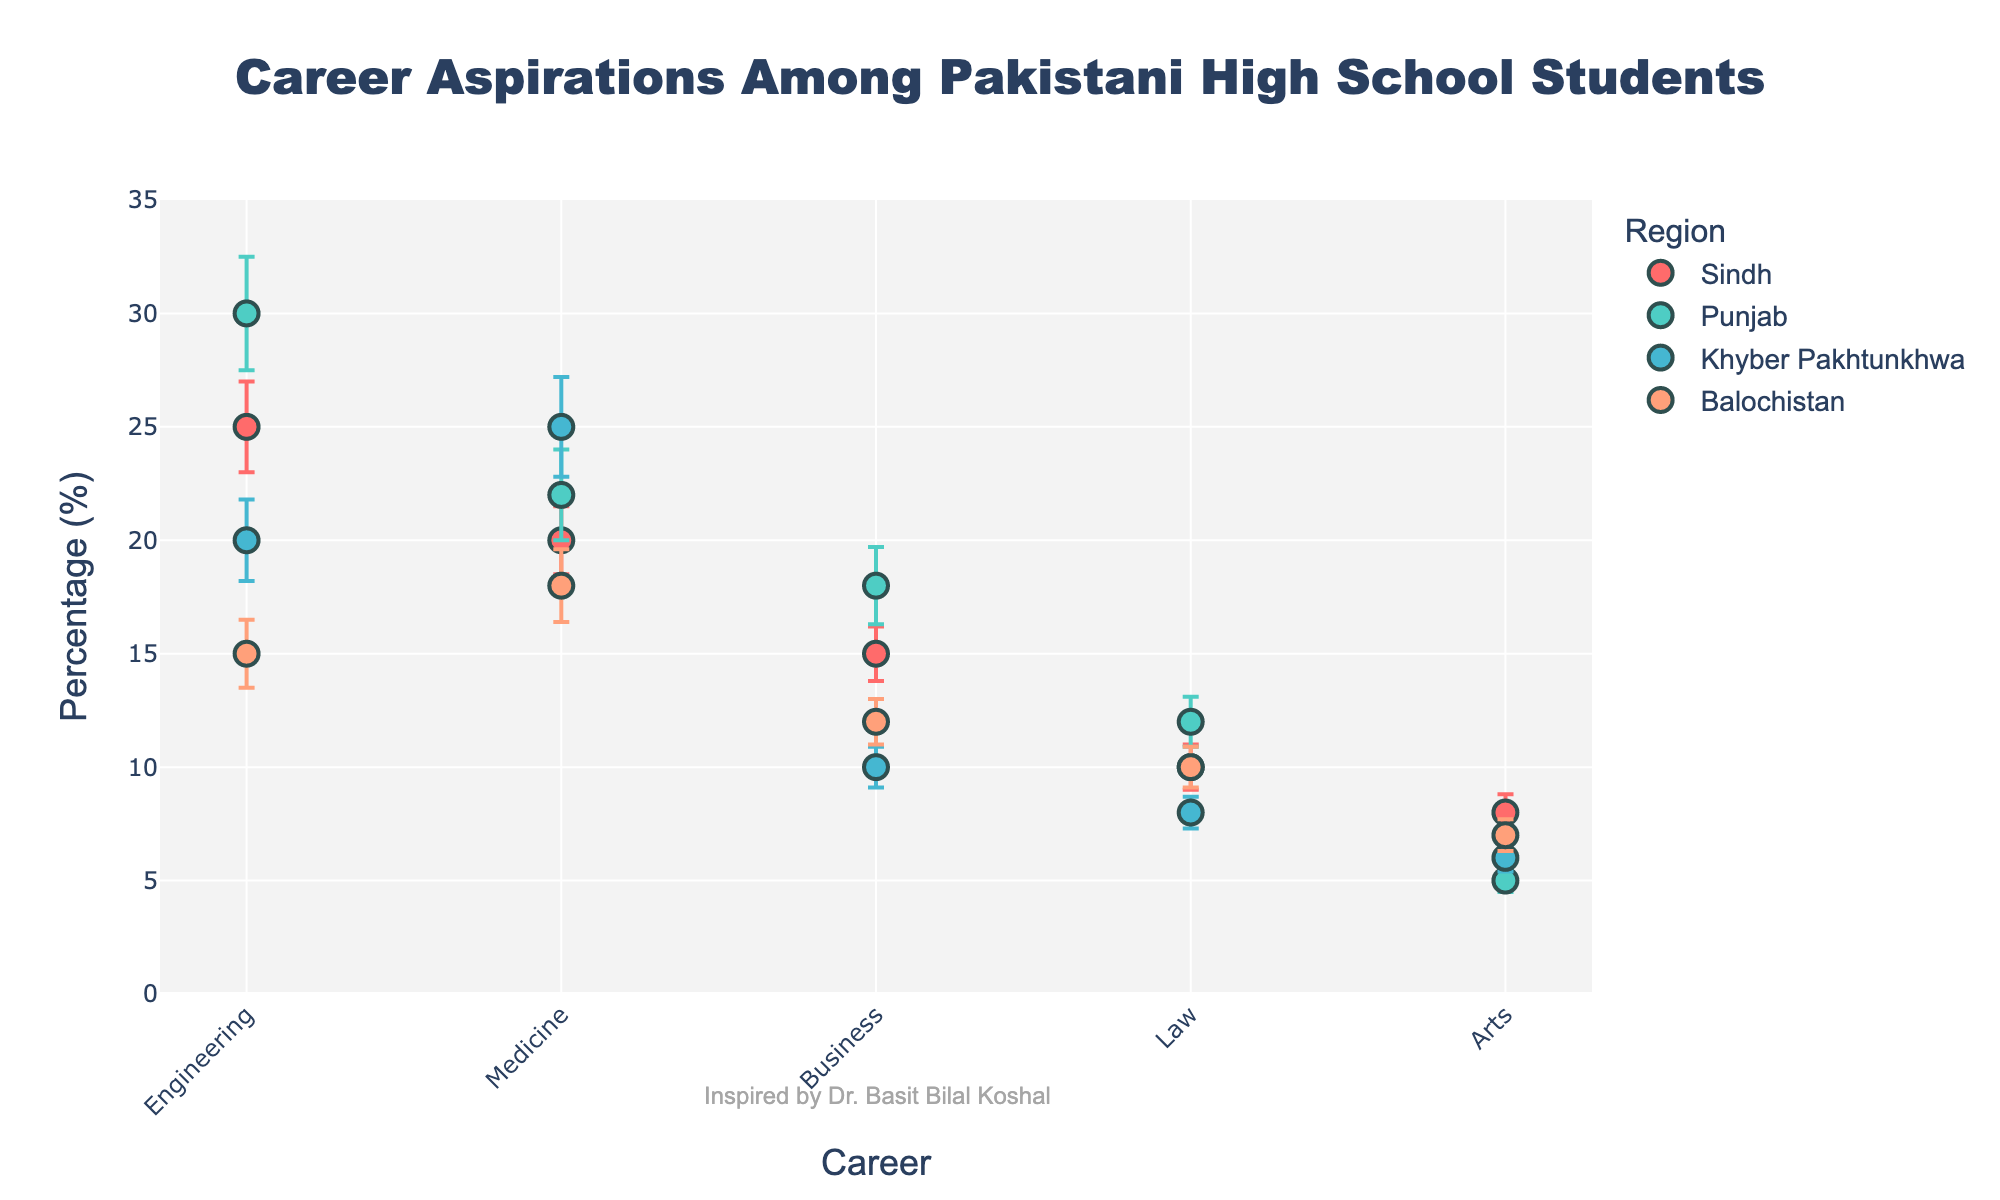What is the title of the figure? The title is typically displayed at the top of the plot and provides an overview of what the figure represents. In this case, it states the content of the figure, referring to career aspirations among students.
Answer: Career Aspirations Among Pakistani High School Students Which region has the highest percentage of students aspiring to be engineers? By observing the dot plot, we can see which dot corresponds to the highest percentage for the career 'Engineering'.
Answer: Punjab What is the approximate error for students aspiring to study medicine in Sindh? By looking at the error bars attached to the dot representing the percentage of students aspiring to study medicine in Sindh, we can determine how much variance there is from the main data point.
Answer: 1.5% Which career has the lowest percentage of interest in Punjab? Look at the dots for all careers in Punjab and identify the one with the smallest y-value.
Answer: Arts How does the percentage of students interested in business compare between Sindh and Punjab? Compare the y-values of the dots representing 'Business' for both Sindh and Punjab to determine the relative percentages.
Answer: Punjab has a higher percentage (18% vs. 15%) What is the difference in percentage between students aspiring to pursue law in Balochistan versus Khyber Pakhtunkhwa? Look at the y-values for 'Law' for both Balochistan and Khyber Pakhtunkhwa and compute the difference. 10% - 8% = 2%.
Answer: 2% Which region has the most varied career aspirations based on the error bars? Observe the length of the error bars for each career in each region to determine which region shows the most variation.
Answer: Punjab List the regions in descending order of interest in the arts. Compare the y-values of 'Arts' for all regions and order them from highest to lowest.
Answer: Sindh > Balochistan > Khyber Pakhtunkhwa > Punjab What is the average percentage of students interested in engineering across all regions? To find the average: (25 + 30 + 20 + 15) / 4 = 22.5%
Answer: 22.5% How much higher is the percentage of students interested in medicine in Khyber Pakhtunkhwa compared to Sindh? Compare the y-values for 'Medicine' in Khyber Pakhtunkhwa and Sindh and calculate the difference: 25% - 20% = 5%.
Answer: 5% 